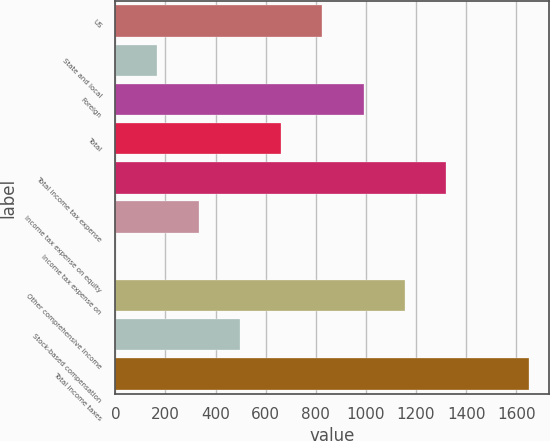Convert chart to OTSL. <chart><loc_0><loc_0><loc_500><loc_500><bar_chart><fcel>US<fcel>State and local<fcel>Foreign<fcel>Total<fcel>Total income tax expense<fcel>Income tax expense on equity<fcel>Income tax expense on<fcel>Other comprehensive income<fcel>Stock-based compensation<fcel>Total income taxes<nl><fcel>826.5<fcel>167.7<fcel>991.2<fcel>661.8<fcel>1320.6<fcel>332.4<fcel>3<fcel>1155.9<fcel>497.1<fcel>1650<nl></chart> 